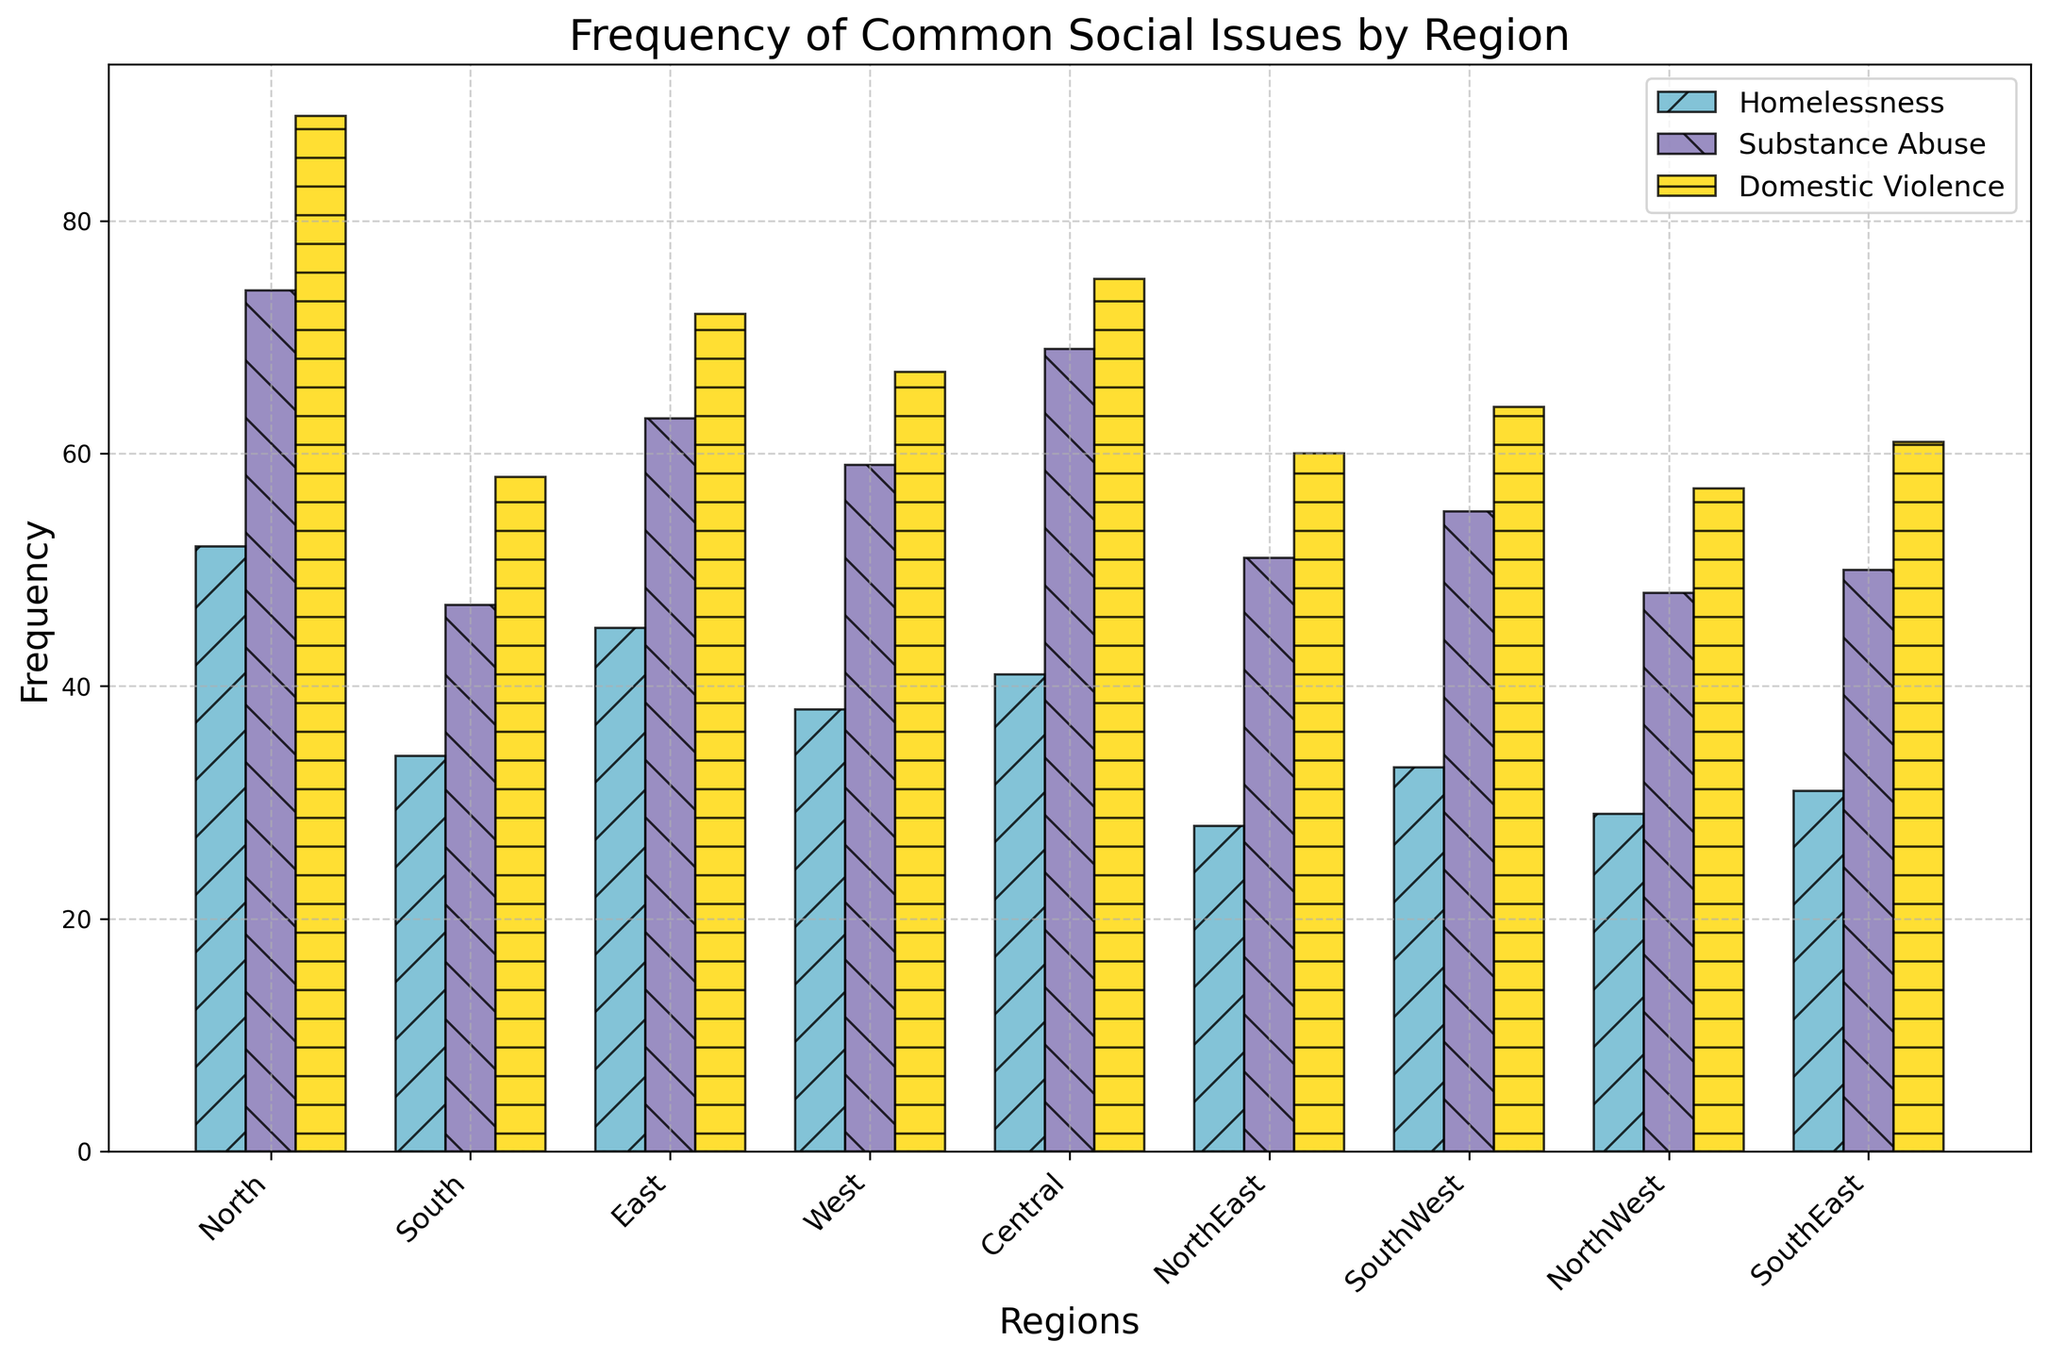Which region reports the highest frequency of domestic violence cases? Observe the height of the bars labeled 'Domestic Violence' for each region. The one with the tallest bar indicates the highest frequency. North has the highest bar for Domestic Violence cases.
Answer: North What is the difference in the number of homelessness cases reported between the North and the NorthEast regions? Look at the 'Homelessness' bars for North and NorthEast. The North has 52 and NorthEast has 28. Calculate the difference: 52 - 28 = 24.
Answer: 24 In which region is the frequency of substance abuse cases approximately equal to the frequency of domestic violence cases? Compare the 'Substance Abuse' and 'Domestic Violence' bars for each region. For Central, substance abuse is 69 and domestic violence is 75, which are close.
Answer: Central Which social issue has the smallest frequency in the SouthWest region, and what is its value? Look at the bars for SouthWest. Compare the heights of bars for Homelessness, Substance Abuse, and Domestic Violence. Homelessness has the smallest bar with a value of 33.
Answer: Homelessness, 33 What is the total frequency of all reported social issues in the North region? Sum the frequencies of Homelessness, Substance Abuse, and Domestic Violence in the North: 52 + 74 + 89 = 215.
Answer: 215 Which region has the lowest reported frequency of substance abuse cases, and what is its value? Check the 'Substance Abuse' bars across regions. NorthWest has the lowest bar with a value of 48.
Answer: NorthWest, 48 Calculate the average number of domestic violence cases reported across all regions. Add the values of Domestic Violence for all regions and divide by the number of regions (9): (89 + 58 + 72 + 67 + 75 + 60 + 64 + 57 + 61) / 9 = 603 / 9.
Answer: 67 In which region is the height of the homelessness bar less than the height of the domestic violence bar, but greater than the height of the substance abuse bar? Compare the heights of the bars related to Homelessness, Substance Abuse, and Domestic Violence in each region. In the East, Homelessness (45) is less than Domestic Violence (72) but greater than Substance Abuse (63).
Answer: East What is the combined frequency of homelessness cases reported in the South and West regions? Add the homelessness numbers for South and West: 34 + 38 = 72.
Answer: 72 Compare the regions NorthEast and SouthEast for substance abuse cases and identify which region reports more cases. Compare the heights of the 'Substance Abuse' bars. NorthEast reports 51 cases, and SouthEast reports 50 cases. NorthEast reports more.
Answer: NorthEast 